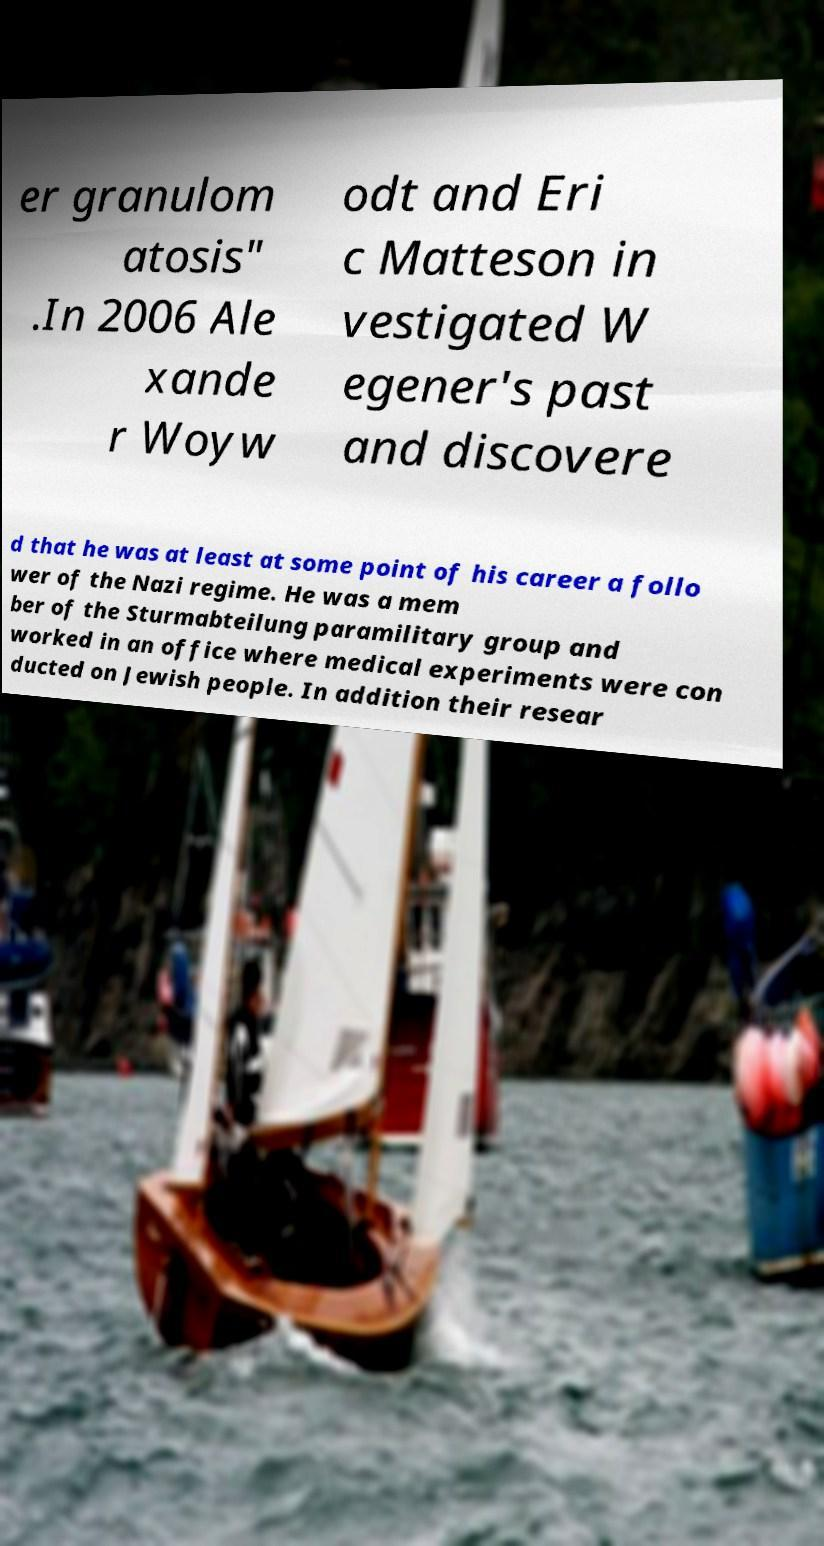Please read and relay the text visible in this image. What does it say? er granulom atosis" .In 2006 Ale xande r Woyw odt and Eri c Matteson in vestigated W egener's past and discovere d that he was at least at some point of his career a follo wer of the Nazi regime. He was a mem ber of the Sturmabteilung paramilitary group and worked in an office where medical experiments were con ducted on Jewish people. In addition their resear 